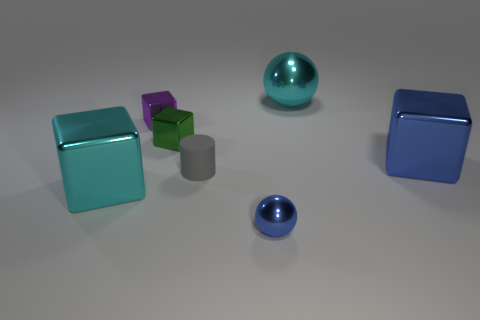Subtract all big blue shiny cubes. How many cubes are left? 3 Add 1 large blue shiny objects. How many objects exist? 8 Subtract all blue balls. How many balls are left? 1 Subtract 3 cubes. How many cubes are left? 1 Subtract all cylinders. How many objects are left? 6 Subtract all yellow balls. Subtract all cyan cubes. How many balls are left? 2 Subtract all large purple rubber spheres. Subtract all small gray cylinders. How many objects are left? 6 Add 6 rubber cylinders. How many rubber cylinders are left? 7 Add 1 small green cylinders. How many small green cylinders exist? 1 Subtract 0 gray spheres. How many objects are left? 7 